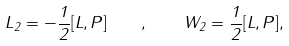Convert formula to latex. <formula><loc_0><loc_0><loc_500><loc_500>L _ { 2 } = - \frac { 1 } { 2 } [ L , P ] \quad , \quad W _ { 2 } = \frac { 1 } { 2 } [ L , P ] ,</formula> 